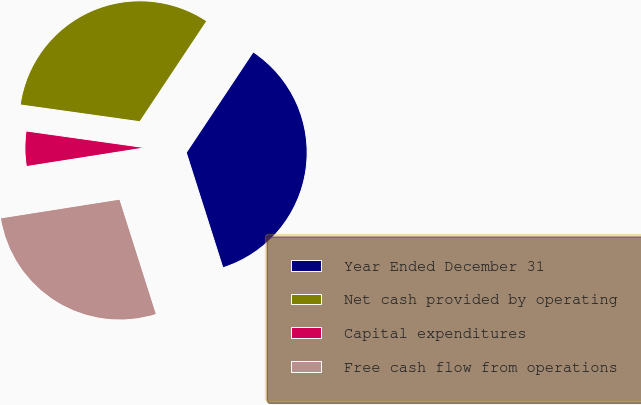Convert chart to OTSL. <chart><loc_0><loc_0><loc_500><loc_500><pie_chart><fcel>Year Ended December 31<fcel>Net cash provided by operating<fcel>Capital expenditures<fcel>Free cash flow from operations<nl><fcel>35.76%<fcel>32.12%<fcel>4.71%<fcel>27.41%<nl></chart> 